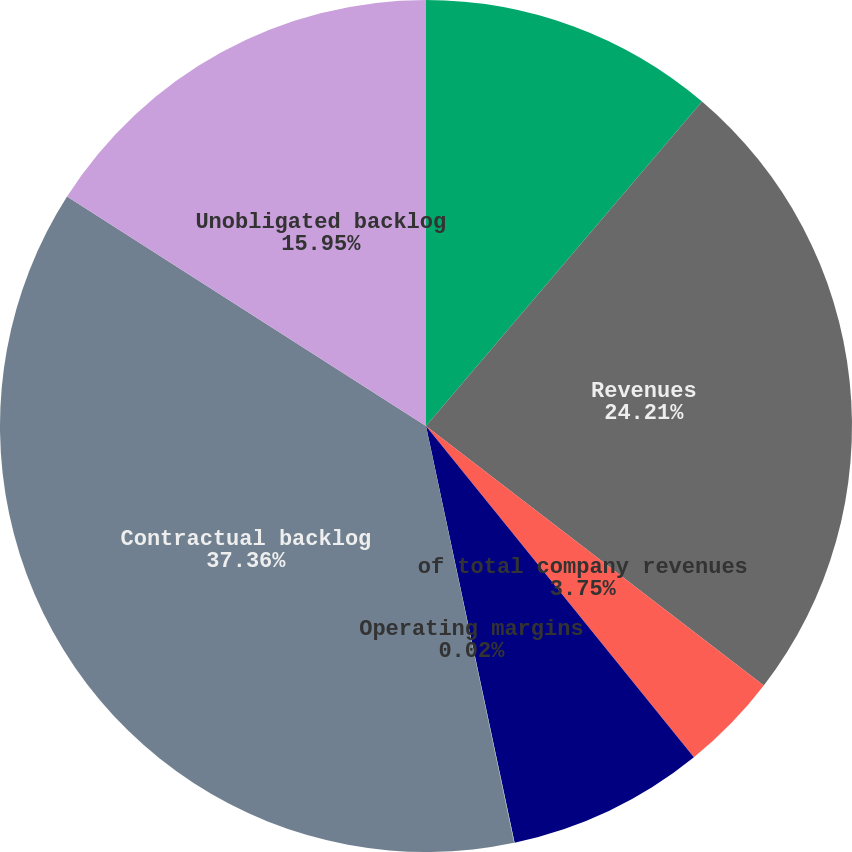Convert chart to OTSL. <chart><loc_0><loc_0><loc_500><loc_500><pie_chart><fcel>(Dollars in millions) Years<fcel>Revenues<fcel>of total company revenues<fcel>Earnings from operations<fcel>Operating margins<fcel>Contractual backlog<fcel>Unobligated backlog<nl><fcel>11.22%<fcel>24.21%<fcel>3.75%<fcel>7.49%<fcel>0.02%<fcel>37.37%<fcel>15.95%<nl></chart> 